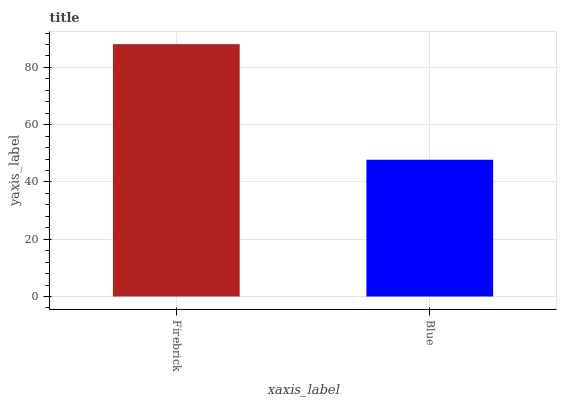Is Blue the minimum?
Answer yes or no. Yes. Is Firebrick the maximum?
Answer yes or no. Yes. Is Blue the maximum?
Answer yes or no. No. Is Firebrick greater than Blue?
Answer yes or no. Yes. Is Blue less than Firebrick?
Answer yes or no. Yes. Is Blue greater than Firebrick?
Answer yes or no. No. Is Firebrick less than Blue?
Answer yes or no. No. Is Firebrick the high median?
Answer yes or no. Yes. Is Blue the low median?
Answer yes or no. Yes. Is Blue the high median?
Answer yes or no. No. Is Firebrick the low median?
Answer yes or no. No. 